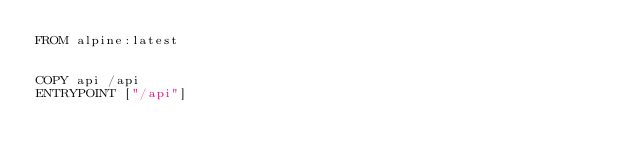<code> <loc_0><loc_0><loc_500><loc_500><_Dockerfile_>FROM alpine:latest


COPY api /api
ENTRYPOINT ["/api"]

</code> 